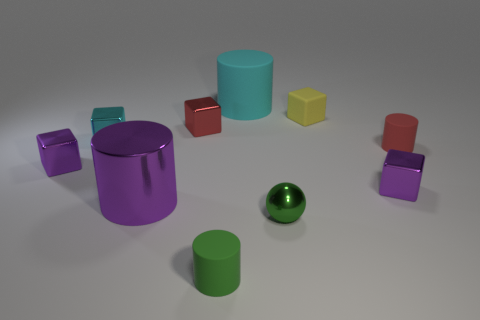Subtract all cyan blocks. How many blocks are left? 4 Subtract all purple cylinders. How many cylinders are left? 3 Subtract all spheres. How many objects are left? 9 Add 2 big green metallic objects. How many big green metallic objects exist? 2 Subtract 1 red blocks. How many objects are left? 9 Subtract 1 balls. How many balls are left? 0 Subtract all brown cylinders. Subtract all cyan blocks. How many cylinders are left? 4 Subtract all brown cylinders. How many red balls are left? 0 Subtract all tiny green balls. Subtract all cyan objects. How many objects are left? 7 Add 5 large matte cylinders. How many large matte cylinders are left? 6 